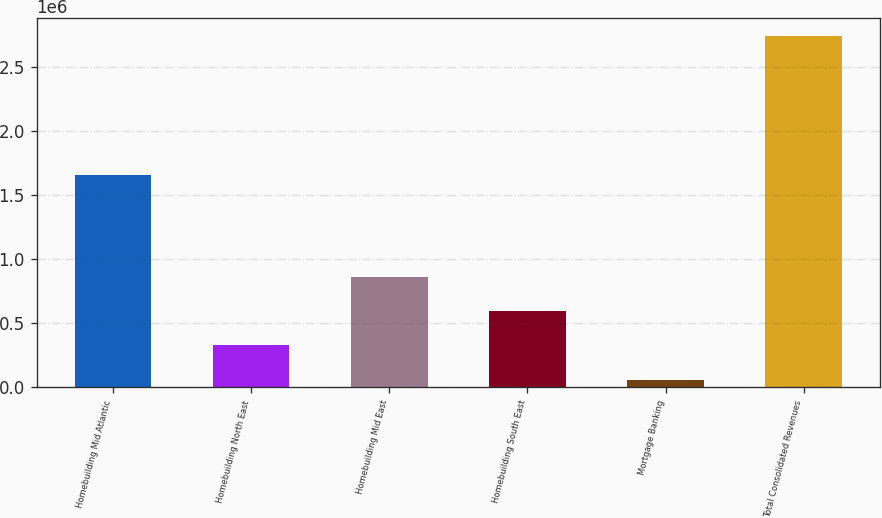Convert chart to OTSL. <chart><loc_0><loc_0><loc_500><loc_500><bar_chart><fcel>Homebuilding Mid Atlantic<fcel>Homebuilding North East<fcel>Homebuilding Mid East<fcel>Homebuilding South East<fcel>Mortgage Banking<fcel>Total Consolidated Revenues<nl><fcel>1.66124e+06<fcel>328728<fcel>865421<fcel>597074<fcel>60381<fcel>2.74385e+06<nl></chart> 